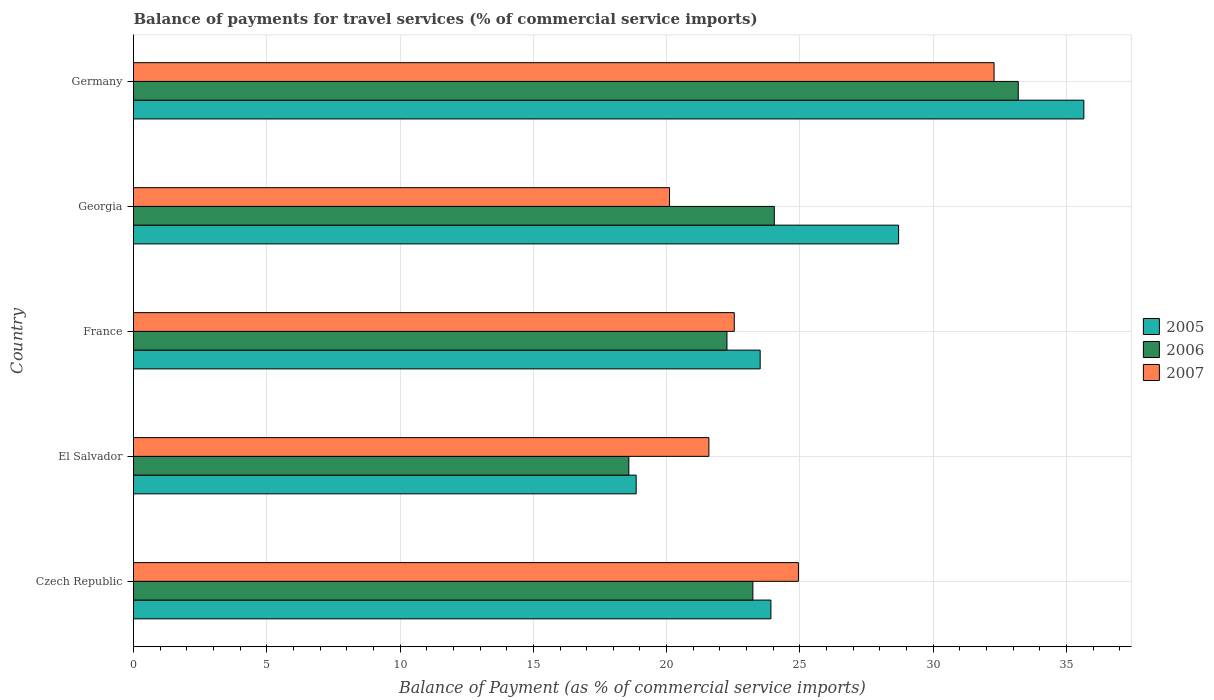How many different coloured bars are there?
Your response must be concise. 3. How many groups of bars are there?
Your answer should be compact. 5. Are the number of bars per tick equal to the number of legend labels?
Keep it short and to the point. Yes. Are the number of bars on each tick of the Y-axis equal?
Your answer should be very brief. Yes. How many bars are there on the 3rd tick from the bottom?
Give a very brief answer. 3. What is the label of the 5th group of bars from the top?
Your answer should be very brief. Czech Republic. In how many cases, is the number of bars for a given country not equal to the number of legend labels?
Your answer should be compact. 0. What is the balance of payments for travel services in 2007 in Germany?
Give a very brief answer. 32.28. Across all countries, what is the maximum balance of payments for travel services in 2006?
Your response must be concise. 33.19. Across all countries, what is the minimum balance of payments for travel services in 2005?
Ensure brevity in your answer.  18.86. In which country was the balance of payments for travel services in 2006 minimum?
Your answer should be very brief. El Salvador. What is the total balance of payments for travel services in 2006 in the graph?
Offer a terse response. 121.31. What is the difference between the balance of payments for travel services in 2005 in Czech Republic and that in France?
Offer a very short reply. 0.4. What is the difference between the balance of payments for travel services in 2006 in El Salvador and the balance of payments for travel services in 2005 in Czech Republic?
Ensure brevity in your answer.  -5.33. What is the average balance of payments for travel services in 2005 per country?
Offer a terse response. 26.13. What is the difference between the balance of payments for travel services in 2006 and balance of payments for travel services in 2005 in Czech Republic?
Your response must be concise. -0.68. What is the ratio of the balance of payments for travel services in 2005 in El Salvador to that in France?
Your response must be concise. 0.8. Is the difference between the balance of payments for travel services in 2006 in Czech Republic and El Salvador greater than the difference between the balance of payments for travel services in 2005 in Czech Republic and El Salvador?
Provide a succinct answer. No. What is the difference between the highest and the second highest balance of payments for travel services in 2005?
Your answer should be very brief. 6.95. What is the difference between the highest and the lowest balance of payments for travel services in 2007?
Your answer should be compact. 12.18. Is the sum of the balance of payments for travel services in 2005 in Czech Republic and El Salvador greater than the maximum balance of payments for travel services in 2007 across all countries?
Your response must be concise. Yes. What does the 1st bar from the bottom in El Salvador represents?
Offer a terse response. 2005. Are the values on the major ticks of X-axis written in scientific E-notation?
Your answer should be very brief. No. Does the graph contain grids?
Your answer should be compact. Yes. Where does the legend appear in the graph?
Make the answer very short. Center right. How many legend labels are there?
Ensure brevity in your answer.  3. How are the legend labels stacked?
Provide a short and direct response. Vertical. What is the title of the graph?
Ensure brevity in your answer.  Balance of payments for travel services (% of commercial service imports). What is the label or title of the X-axis?
Your response must be concise. Balance of Payment (as % of commercial service imports). What is the Balance of Payment (as % of commercial service imports) in 2005 in Czech Republic?
Make the answer very short. 23.91. What is the Balance of Payment (as % of commercial service imports) in 2006 in Czech Republic?
Provide a succinct answer. 23.24. What is the Balance of Payment (as % of commercial service imports) in 2007 in Czech Republic?
Keep it short and to the point. 24.94. What is the Balance of Payment (as % of commercial service imports) of 2005 in El Salvador?
Make the answer very short. 18.86. What is the Balance of Payment (as % of commercial service imports) in 2006 in El Salvador?
Provide a short and direct response. 18.58. What is the Balance of Payment (as % of commercial service imports) of 2007 in El Salvador?
Give a very brief answer. 21.59. What is the Balance of Payment (as % of commercial service imports) in 2005 in France?
Ensure brevity in your answer.  23.51. What is the Balance of Payment (as % of commercial service imports) in 2006 in France?
Your answer should be very brief. 22.26. What is the Balance of Payment (as % of commercial service imports) of 2007 in France?
Provide a succinct answer. 22.54. What is the Balance of Payment (as % of commercial service imports) in 2005 in Georgia?
Give a very brief answer. 28.7. What is the Balance of Payment (as % of commercial service imports) of 2006 in Georgia?
Give a very brief answer. 24.04. What is the Balance of Payment (as % of commercial service imports) of 2007 in Georgia?
Provide a short and direct response. 20.11. What is the Balance of Payment (as % of commercial service imports) of 2005 in Germany?
Provide a short and direct response. 35.65. What is the Balance of Payment (as % of commercial service imports) in 2006 in Germany?
Ensure brevity in your answer.  33.19. What is the Balance of Payment (as % of commercial service imports) of 2007 in Germany?
Offer a terse response. 32.28. Across all countries, what is the maximum Balance of Payment (as % of commercial service imports) in 2005?
Make the answer very short. 35.65. Across all countries, what is the maximum Balance of Payment (as % of commercial service imports) in 2006?
Offer a very short reply. 33.19. Across all countries, what is the maximum Balance of Payment (as % of commercial service imports) of 2007?
Your answer should be very brief. 32.28. Across all countries, what is the minimum Balance of Payment (as % of commercial service imports) of 2005?
Offer a very short reply. 18.86. Across all countries, what is the minimum Balance of Payment (as % of commercial service imports) in 2006?
Ensure brevity in your answer.  18.58. Across all countries, what is the minimum Balance of Payment (as % of commercial service imports) in 2007?
Ensure brevity in your answer.  20.11. What is the total Balance of Payment (as % of commercial service imports) of 2005 in the graph?
Give a very brief answer. 130.63. What is the total Balance of Payment (as % of commercial service imports) in 2006 in the graph?
Ensure brevity in your answer.  121.31. What is the total Balance of Payment (as % of commercial service imports) of 2007 in the graph?
Your answer should be compact. 121.46. What is the difference between the Balance of Payment (as % of commercial service imports) in 2005 in Czech Republic and that in El Salvador?
Your response must be concise. 5.05. What is the difference between the Balance of Payment (as % of commercial service imports) in 2006 in Czech Republic and that in El Salvador?
Provide a short and direct response. 4.65. What is the difference between the Balance of Payment (as % of commercial service imports) of 2007 in Czech Republic and that in El Salvador?
Your answer should be compact. 3.36. What is the difference between the Balance of Payment (as % of commercial service imports) in 2005 in Czech Republic and that in France?
Make the answer very short. 0.4. What is the difference between the Balance of Payment (as % of commercial service imports) in 2006 in Czech Republic and that in France?
Your answer should be compact. 0.97. What is the difference between the Balance of Payment (as % of commercial service imports) in 2007 in Czech Republic and that in France?
Your response must be concise. 2.41. What is the difference between the Balance of Payment (as % of commercial service imports) of 2005 in Czech Republic and that in Georgia?
Your answer should be compact. -4.79. What is the difference between the Balance of Payment (as % of commercial service imports) in 2006 in Czech Republic and that in Georgia?
Keep it short and to the point. -0.8. What is the difference between the Balance of Payment (as % of commercial service imports) in 2007 in Czech Republic and that in Georgia?
Your answer should be very brief. 4.84. What is the difference between the Balance of Payment (as % of commercial service imports) of 2005 in Czech Republic and that in Germany?
Provide a succinct answer. -11.74. What is the difference between the Balance of Payment (as % of commercial service imports) in 2006 in Czech Republic and that in Germany?
Your response must be concise. -9.96. What is the difference between the Balance of Payment (as % of commercial service imports) in 2007 in Czech Republic and that in Germany?
Offer a very short reply. -7.34. What is the difference between the Balance of Payment (as % of commercial service imports) in 2005 in El Salvador and that in France?
Your answer should be compact. -4.65. What is the difference between the Balance of Payment (as % of commercial service imports) of 2006 in El Salvador and that in France?
Your answer should be compact. -3.68. What is the difference between the Balance of Payment (as % of commercial service imports) of 2007 in El Salvador and that in France?
Your answer should be very brief. -0.95. What is the difference between the Balance of Payment (as % of commercial service imports) of 2005 in El Salvador and that in Georgia?
Provide a short and direct response. -9.85. What is the difference between the Balance of Payment (as % of commercial service imports) of 2006 in El Salvador and that in Georgia?
Your response must be concise. -5.46. What is the difference between the Balance of Payment (as % of commercial service imports) of 2007 in El Salvador and that in Georgia?
Your answer should be compact. 1.48. What is the difference between the Balance of Payment (as % of commercial service imports) of 2005 in El Salvador and that in Germany?
Your answer should be compact. -16.79. What is the difference between the Balance of Payment (as % of commercial service imports) in 2006 in El Salvador and that in Germany?
Give a very brief answer. -14.61. What is the difference between the Balance of Payment (as % of commercial service imports) in 2007 in El Salvador and that in Germany?
Your response must be concise. -10.7. What is the difference between the Balance of Payment (as % of commercial service imports) in 2005 in France and that in Georgia?
Your answer should be very brief. -5.19. What is the difference between the Balance of Payment (as % of commercial service imports) in 2006 in France and that in Georgia?
Your answer should be compact. -1.78. What is the difference between the Balance of Payment (as % of commercial service imports) of 2007 in France and that in Georgia?
Give a very brief answer. 2.43. What is the difference between the Balance of Payment (as % of commercial service imports) of 2005 in France and that in Germany?
Your response must be concise. -12.14. What is the difference between the Balance of Payment (as % of commercial service imports) of 2006 in France and that in Germany?
Make the answer very short. -10.93. What is the difference between the Balance of Payment (as % of commercial service imports) in 2007 in France and that in Germany?
Offer a terse response. -9.75. What is the difference between the Balance of Payment (as % of commercial service imports) in 2005 in Georgia and that in Germany?
Offer a terse response. -6.95. What is the difference between the Balance of Payment (as % of commercial service imports) of 2006 in Georgia and that in Germany?
Make the answer very short. -9.15. What is the difference between the Balance of Payment (as % of commercial service imports) in 2007 in Georgia and that in Germany?
Ensure brevity in your answer.  -12.18. What is the difference between the Balance of Payment (as % of commercial service imports) of 2005 in Czech Republic and the Balance of Payment (as % of commercial service imports) of 2006 in El Salvador?
Ensure brevity in your answer.  5.33. What is the difference between the Balance of Payment (as % of commercial service imports) in 2005 in Czech Republic and the Balance of Payment (as % of commercial service imports) in 2007 in El Salvador?
Make the answer very short. 2.33. What is the difference between the Balance of Payment (as % of commercial service imports) of 2006 in Czech Republic and the Balance of Payment (as % of commercial service imports) of 2007 in El Salvador?
Ensure brevity in your answer.  1.65. What is the difference between the Balance of Payment (as % of commercial service imports) in 2005 in Czech Republic and the Balance of Payment (as % of commercial service imports) in 2006 in France?
Your answer should be very brief. 1.65. What is the difference between the Balance of Payment (as % of commercial service imports) of 2005 in Czech Republic and the Balance of Payment (as % of commercial service imports) of 2007 in France?
Your response must be concise. 1.37. What is the difference between the Balance of Payment (as % of commercial service imports) in 2006 in Czech Republic and the Balance of Payment (as % of commercial service imports) in 2007 in France?
Offer a terse response. 0.7. What is the difference between the Balance of Payment (as % of commercial service imports) in 2005 in Czech Republic and the Balance of Payment (as % of commercial service imports) in 2006 in Georgia?
Keep it short and to the point. -0.13. What is the difference between the Balance of Payment (as % of commercial service imports) in 2005 in Czech Republic and the Balance of Payment (as % of commercial service imports) in 2007 in Georgia?
Your response must be concise. 3.8. What is the difference between the Balance of Payment (as % of commercial service imports) in 2006 in Czech Republic and the Balance of Payment (as % of commercial service imports) in 2007 in Georgia?
Give a very brief answer. 3.13. What is the difference between the Balance of Payment (as % of commercial service imports) in 2005 in Czech Republic and the Balance of Payment (as % of commercial service imports) in 2006 in Germany?
Your response must be concise. -9.28. What is the difference between the Balance of Payment (as % of commercial service imports) in 2005 in Czech Republic and the Balance of Payment (as % of commercial service imports) in 2007 in Germany?
Ensure brevity in your answer.  -8.37. What is the difference between the Balance of Payment (as % of commercial service imports) of 2006 in Czech Republic and the Balance of Payment (as % of commercial service imports) of 2007 in Germany?
Ensure brevity in your answer.  -9.05. What is the difference between the Balance of Payment (as % of commercial service imports) in 2005 in El Salvador and the Balance of Payment (as % of commercial service imports) in 2006 in France?
Your response must be concise. -3.41. What is the difference between the Balance of Payment (as % of commercial service imports) in 2005 in El Salvador and the Balance of Payment (as % of commercial service imports) in 2007 in France?
Provide a short and direct response. -3.68. What is the difference between the Balance of Payment (as % of commercial service imports) in 2006 in El Salvador and the Balance of Payment (as % of commercial service imports) in 2007 in France?
Ensure brevity in your answer.  -3.96. What is the difference between the Balance of Payment (as % of commercial service imports) of 2005 in El Salvador and the Balance of Payment (as % of commercial service imports) of 2006 in Georgia?
Offer a terse response. -5.18. What is the difference between the Balance of Payment (as % of commercial service imports) of 2005 in El Salvador and the Balance of Payment (as % of commercial service imports) of 2007 in Georgia?
Give a very brief answer. -1.25. What is the difference between the Balance of Payment (as % of commercial service imports) of 2006 in El Salvador and the Balance of Payment (as % of commercial service imports) of 2007 in Georgia?
Your answer should be very brief. -1.53. What is the difference between the Balance of Payment (as % of commercial service imports) of 2005 in El Salvador and the Balance of Payment (as % of commercial service imports) of 2006 in Germany?
Give a very brief answer. -14.33. What is the difference between the Balance of Payment (as % of commercial service imports) in 2005 in El Salvador and the Balance of Payment (as % of commercial service imports) in 2007 in Germany?
Your answer should be very brief. -13.43. What is the difference between the Balance of Payment (as % of commercial service imports) of 2006 in El Salvador and the Balance of Payment (as % of commercial service imports) of 2007 in Germany?
Ensure brevity in your answer.  -13.7. What is the difference between the Balance of Payment (as % of commercial service imports) of 2005 in France and the Balance of Payment (as % of commercial service imports) of 2006 in Georgia?
Your answer should be very brief. -0.53. What is the difference between the Balance of Payment (as % of commercial service imports) in 2005 in France and the Balance of Payment (as % of commercial service imports) in 2007 in Georgia?
Offer a very short reply. 3.4. What is the difference between the Balance of Payment (as % of commercial service imports) of 2006 in France and the Balance of Payment (as % of commercial service imports) of 2007 in Georgia?
Give a very brief answer. 2.15. What is the difference between the Balance of Payment (as % of commercial service imports) of 2005 in France and the Balance of Payment (as % of commercial service imports) of 2006 in Germany?
Make the answer very short. -9.68. What is the difference between the Balance of Payment (as % of commercial service imports) in 2005 in France and the Balance of Payment (as % of commercial service imports) in 2007 in Germany?
Offer a very short reply. -8.77. What is the difference between the Balance of Payment (as % of commercial service imports) of 2006 in France and the Balance of Payment (as % of commercial service imports) of 2007 in Germany?
Offer a terse response. -10.02. What is the difference between the Balance of Payment (as % of commercial service imports) of 2005 in Georgia and the Balance of Payment (as % of commercial service imports) of 2006 in Germany?
Your response must be concise. -4.49. What is the difference between the Balance of Payment (as % of commercial service imports) in 2005 in Georgia and the Balance of Payment (as % of commercial service imports) in 2007 in Germany?
Provide a succinct answer. -3.58. What is the difference between the Balance of Payment (as % of commercial service imports) of 2006 in Georgia and the Balance of Payment (as % of commercial service imports) of 2007 in Germany?
Your answer should be compact. -8.24. What is the average Balance of Payment (as % of commercial service imports) in 2005 per country?
Provide a short and direct response. 26.13. What is the average Balance of Payment (as % of commercial service imports) in 2006 per country?
Your response must be concise. 24.26. What is the average Balance of Payment (as % of commercial service imports) in 2007 per country?
Provide a succinct answer. 24.29. What is the difference between the Balance of Payment (as % of commercial service imports) in 2005 and Balance of Payment (as % of commercial service imports) in 2006 in Czech Republic?
Ensure brevity in your answer.  0.68. What is the difference between the Balance of Payment (as % of commercial service imports) of 2005 and Balance of Payment (as % of commercial service imports) of 2007 in Czech Republic?
Make the answer very short. -1.03. What is the difference between the Balance of Payment (as % of commercial service imports) in 2006 and Balance of Payment (as % of commercial service imports) in 2007 in Czech Republic?
Keep it short and to the point. -1.71. What is the difference between the Balance of Payment (as % of commercial service imports) of 2005 and Balance of Payment (as % of commercial service imports) of 2006 in El Salvador?
Your answer should be compact. 0.28. What is the difference between the Balance of Payment (as % of commercial service imports) in 2005 and Balance of Payment (as % of commercial service imports) in 2007 in El Salvador?
Keep it short and to the point. -2.73. What is the difference between the Balance of Payment (as % of commercial service imports) in 2006 and Balance of Payment (as % of commercial service imports) in 2007 in El Salvador?
Give a very brief answer. -3. What is the difference between the Balance of Payment (as % of commercial service imports) in 2005 and Balance of Payment (as % of commercial service imports) in 2006 in France?
Keep it short and to the point. 1.25. What is the difference between the Balance of Payment (as % of commercial service imports) of 2005 and Balance of Payment (as % of commercial service imports) of 2007 in France?
Offer a very short reply. 0.97. What is the difference between the Balance of Payment (as % of commercial service imports) of 2006 and Balance of Payment (as % of commercial service imports) of 2007 in France?
Your response must be concise. -0.27. What is the difference between the Balance of Payment (as % of commercial service imports) of 2005 and Balance of Payment (as % of commercial service imports) of 2006 in Georgia?
Provide a short and direct response. 4.66. What is the difference between the Balance of Payment (as % of commercial service imports) of 2005 and Balance of Payment (as % of commercial service imports) of 2007 in Georgia?
Provide a short and direct response. 8.59. What is the difference between the Balance of Payment (as % of commercial service imports) in 2006 and Balance of Payment (as % of commercial service imports) in 2007 in Georgia?
Ensure brevity in your answer.  3.93. What is the difference between the Balance of Payment (as % of commercial service imports) in 2005 and Balance of Payment (as % of commercial service imports) in 2006 in Germany?
Ensure brevity in your answer.  2.46. What is the difference between the Balance of Payment (as % of commercial service imports) in 2005 and Balance of Payment (as % of commercial service imports) in 2007 in Germany?
Ensure brevity in your answer.  3.37. What is the difference between the Balance of Payment (as % of commercial service imports) in 2006 and Balance of Payment (as % of commercial service imports) in 2007 in Germany?
Provide a short and direct response. 0.91. What is the ratio of the Balance of Payment (as % of commercial service imports) of 2005 in Czech Republic to that in El Salvador?
Offer a very short reply. 1.27. What is the ratio of the Balance of Payment (as % of commercial service imports) in 2006 in Czech Republic to that in El Salvador?
Your response must be concise. 1.25. What is the ratio of the Balance of Payment (as % of commercial service imports) in 2007 in Czech Republic to that in El Salvador?
Make the answer very short. 1.16. What is the ratio of the Balance of Payment (as % of commercial service imports) of 2005 in Czech Republic to that in France?
Provide a short and direct response. 1.02. What is the ratio of the Balance of Payment (as % of commercial service imports) of 2006 in Czech Republic to that in France?
Ensure brevity in your answer.  1.04. What is the ratio of the Balance of Payment (as % of commercial service imports) of 2007 in Czech Republic to that in France?
Keep it short and to the point. 1.11. What is the ratio of the Balance of Payment (as % of commercial service imports) in 2005 in Czech Republic to that in Georgia?
Make the answer very short. 0.83. What is the ratio of the Balance of Payment (as % of commercial service imports) in 2006 in Czech Republic to that in Georgia?
Your response must be concise. 0.97. What is the ratio of the Balance of Payment (as % of commercial service imports) in 2007 in Czech Republic to that in Georgia?
Give a very brief answer. 1.24. What is the ratio of the Balance of Payment (as % of commercial service imports) of 2005 in Czech Republic to that in Germany?
Your response must be concise. 0.67. What is the ratio of the Balance of Payment (as % of commercial service imports) in 2006 in Czech Republic to that in Germany?
Keep it short and to the point. 0.7. What is the ratio of the Balance of Payment (as % of commercial service imports) in 2007 in Czech Republic to that in Germany?
Provide a succinct answer. 0.77. What is the ratio of the Balance of Payment (as % of commercial service imports) of 2005 in El Salvador to that in France?
Make the answer very short. 0.8. What is the ratio of the Balance of Payment (as % of commercial service imports) of 2006 in El Salvador to that in France?
Your answer should be compact. 0.83. What is the ratio of the Balance of Payment (as % of commercial service imports) in 2007 in El Salvador to that in France?
Offer a terse response. 0.96. What is the ratio of the Balance of Payment (as % of commercial service imports) of 2005 in El Salvador to that in Georgia?
Offer a terse response. 0.66. What is the ratio of the Balance of Payment (as % of commercial service imports) of 2006 in El Salvador to that in Georgia?
Provide a succinct answer. 0.77. What is the ratio of the Balance of Payment (as % of commercial service imports) of 2007 in El Salvador to that in Georgia?
Your response must be concise. 1.07. What is the ratio of the Balance of Payment (as % of commercial service imports) in 2005 in El Salvador to that in Germany?
Keep it short and to the point. 0.53. What is the ratio of the Balance of Payment (as % of commercial service imports) in 2006 in El Salvador to that in Germany?
Provide a succinct answer. 0.56. What is the ratio of the Balance of Payment (as % of commercial service imports) of 2007 in El Salvador to that in Germany?
Provide a succinct answer. 0.67. What is the ratio of the Balance of Payment (as % of commercial service imports) of 2005 in France to that in Georgia?
Provide a succinct answer. 0.82. What is the ratio of the Balance of Payment (as % of commercial service imports) in 2006 in France to that in Georgia?
Give a very brief answer. 0.93. What is the ratio of the Balance of Payment (as % of commercial service imports) of 2007 in France to that in Georgia?
Your answer should be compact. 1.12. What is the ratio of the Balance of Payment (as % of commercial service imports) of 2005 in France to that in Germany?
Offer a very short reply. 0.66. What is the ratio of the Balance of Payment (as % of commercial service imports) of 2006 in France to that in Germany?
Your answer should be compact. 0.67. What is the ratio of the Balance of Payment (as % of commercial service imports) in 2007 in France to that in Germany?
Ensure brevity in your answer.  0.7. What is the ratio of the Balance of Payment (as % of commercial service imports) in 2005 in Georgia to that in Germany?
Offer a terse response. 0.81. What is the ratio of the Balance of Payment (as % of commercial service imports) of 2006 in Georgia to that in Germany?
Your answer should be very brief. 0.72. What is the ratio of the Balance of Payment (as % of commercial service imports) in 2007 in Georgia to that in Germany?
Offer a very short reply. 0.62. What is the difference between the highest and the second highest Balance of Payment (as % of commercial service imports) in 2005?
Provide a succinct answer. 6.95. What is the difference between the highest and the second highest Balance of Payment (as % of commercial service imports) of 2006?
Offer a very short reply. 9.15. What is the difference between the highest and the second highest Balance of Payment (as % of commercial service imports) of 2007?
Your answer should be very brief. 7.34. What is the difference between the highest and the lowest Balance of Payment (as % of commercial service imports) in 2005?
Your response must be concise. 16.79. What is the difference between the highest and the lowest Balance of Payment (as % of commercial service imports) of 2006?
Your answer should be very brief. 14.61. What is the difference between the highest and the lowest Balance of Payment (as % of commercial service imports) in 2007?
Provide a short and direct response. 12.18. 